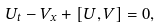Convert formula to latex. <formula><loc_0><loc_0><loc_500><loc_500>U _ { t } - V _ { x } + [ U , V ] = 0 ,</formula> 